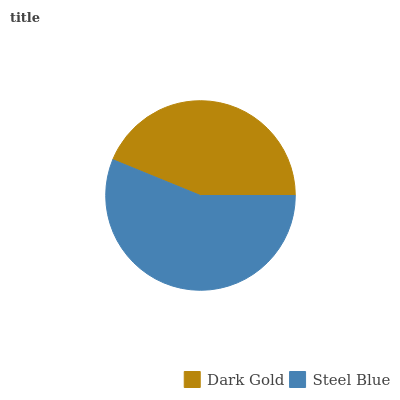Is Dark Gold the minimum?
Answer yes or no. Yes. Is Steel Blue the maximum?
Answer yes or no. Yes. Is Steel Blue the minimum?
Answer yes or no. No. Is Steel Blue greater than Dark Gold?
Answer yes or no. Yes. Is Dark Gold less than Steel Blue?
Answer yes or no. Yes. Is Dark Gold greater than Steel Blue?
Answer yes or no. No. Is Steel Blue less than Dark Gold?
Answer yes or no. No. Is Steel Blue the high median?
Answer yes or no. Yes. Is Dark Gold the low median?
Answer yes or no. Yes. Is Dark Gold the high median?
Answer yes or no. No. Is Steel Blue the low median?
Answer yes or no. No. 